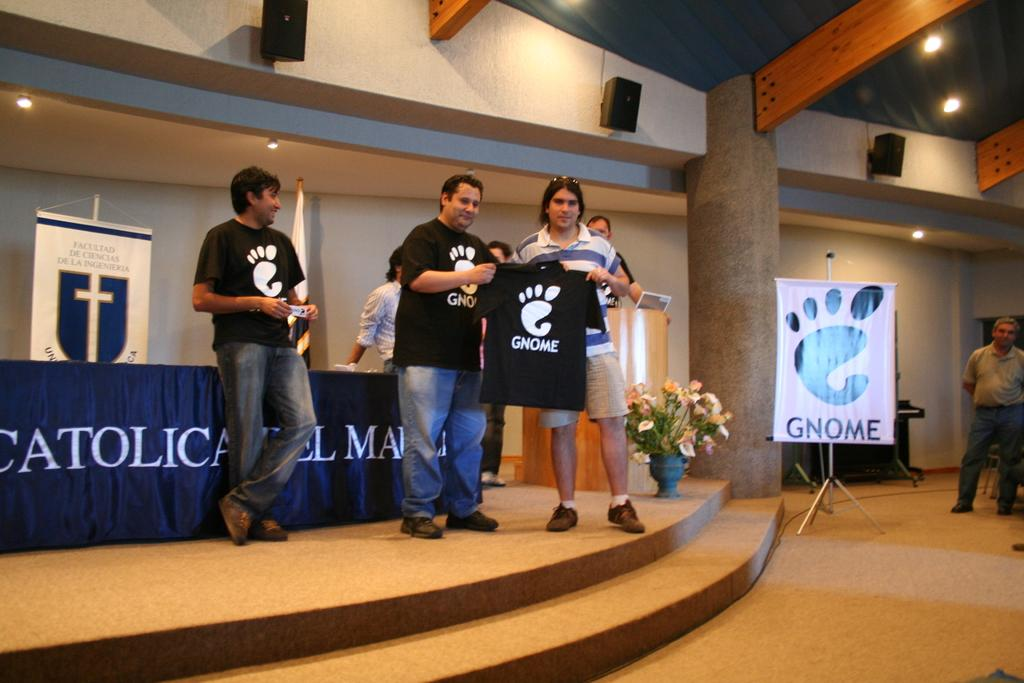<image>
Offer a succinct explanation of the picture presented. People stand on the stage at a church wearing Gnome t-shirts. 